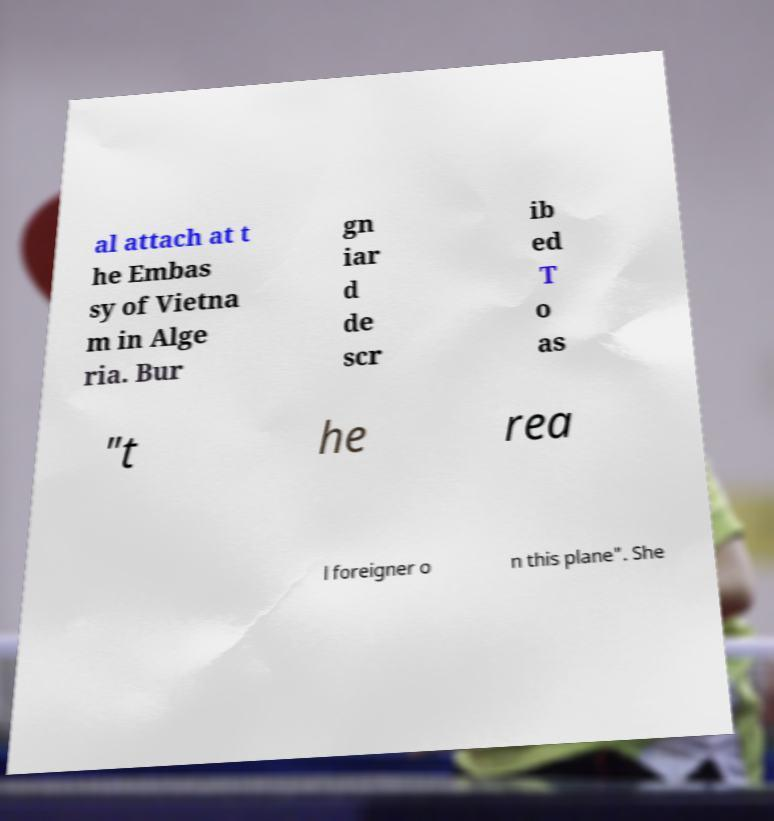I need the written content from this picture converted into text. Can you do that? al attach at t he Embas sy of Vietna m in Alge ria. Bur gn iar d de scr ib ed T o as "t he rea l foreigner o n this plane". She 